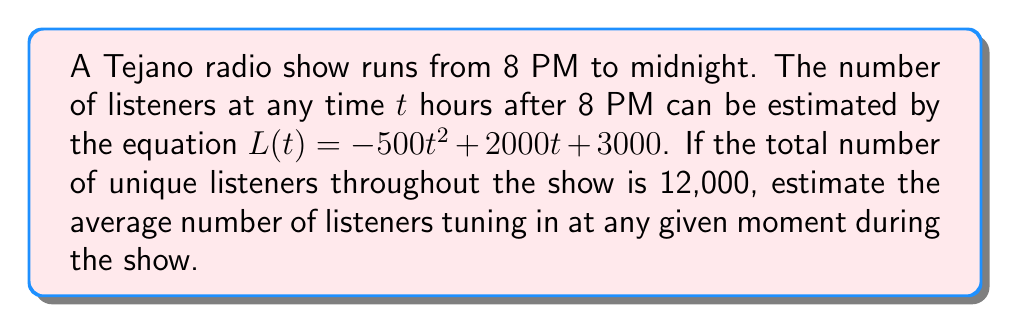Can you solve this math problem? Let's approach this step-by-step:

1) First, we need to find the average number of listeners over the 4-hour period. We can do this by calculating the integral of L(t) from 0 to 4 and dividing by 4.

2) The integral of L(t) from 0 to 4 is:

   $$\int_0^4 (-500t^2 + 2000t + 3000) dt$$

3) Solving this integral:
   $$[-\frac{500}{3}t^3 + 1000t^2 + 3000t]_0^4$$
   $$= (-\frac{500}{3}(64) + 1000(16) + 3000(4)) - (0 + 0 + 0)$$
   $$= (-10666.67 + 16000 + 12000)$$
   $$= 17333.33$$

4) This represents the total listener-hours over the 4-hour period. Dividing by 4 gives us the average number of listeners at any given moment:

   $$17333.33 / 4 = 4333.33$$

5) However, we're told that there are 12,000 unique listeners throughout the show. This means that not everyone is listening for the entire duration.

6) Let's define x as the fraction of the show that the average listener tunes in for. Then:

   $$4333.33 * x = 12000$$

7) Solving for x:
   $$x = 12000 / 4333.33 = 2.77$$

8) This means that the average listener tunes in for 2.77 times as long as we initially calculated. Therefore, our final estimate is:

   $$4333.33 * 2.77 = 12003.32$$
Answer: Approximately 12,003 listeners 